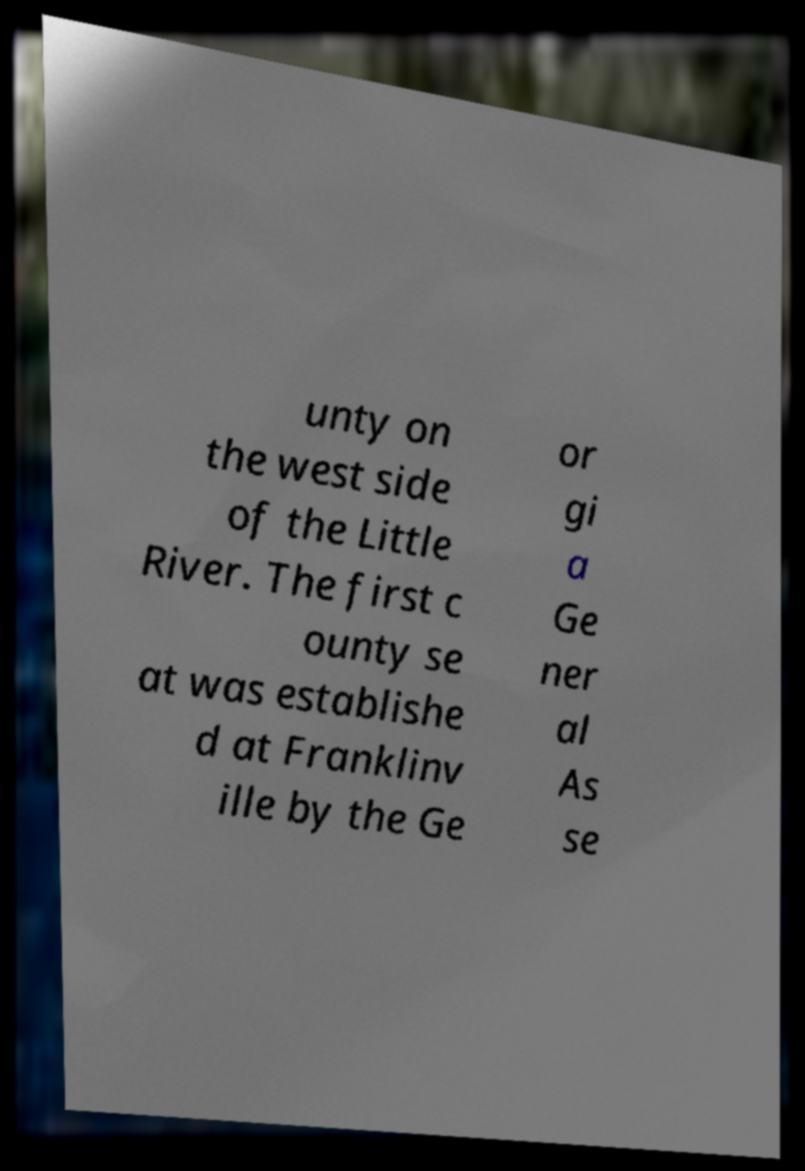Can you read and provide the text displayed in the image?This photo seems to have some interesting text. Can you extract and type it out for me? unty on the west side of the Little River. The first c ounty se at was establishe d at Franklinv ille by the Ge or gi a Ge ner al As se 